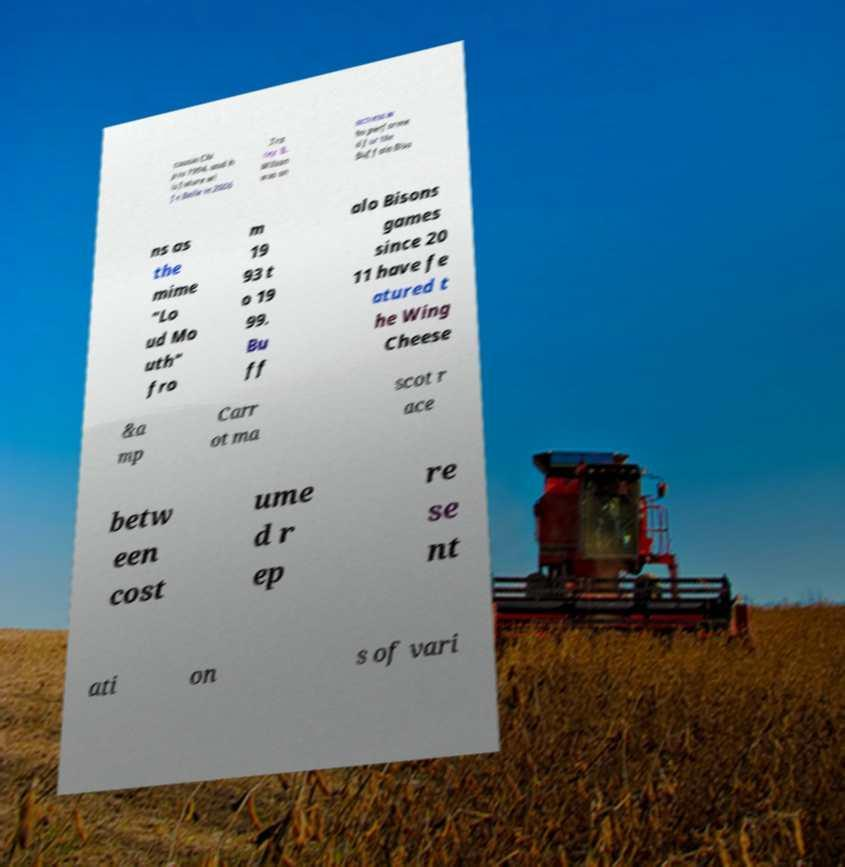Please read and relay the text visible in this image. What does it say? cousin Chi p in 1994, and h is future wi fe Belle in 2006 .Tra cey B. Wilson was an actress w ho performe d for the Buffalo Biso ns as the mime "Lo ud Mo uth" fro m 19 93 t o 19 99. Bu ff alo Bisons games since 20 11 have fe atured t he Wing Cheese &a mp Carr ot ma scot r ace betw een cost ume d r ep re se nt ati on s of vari 